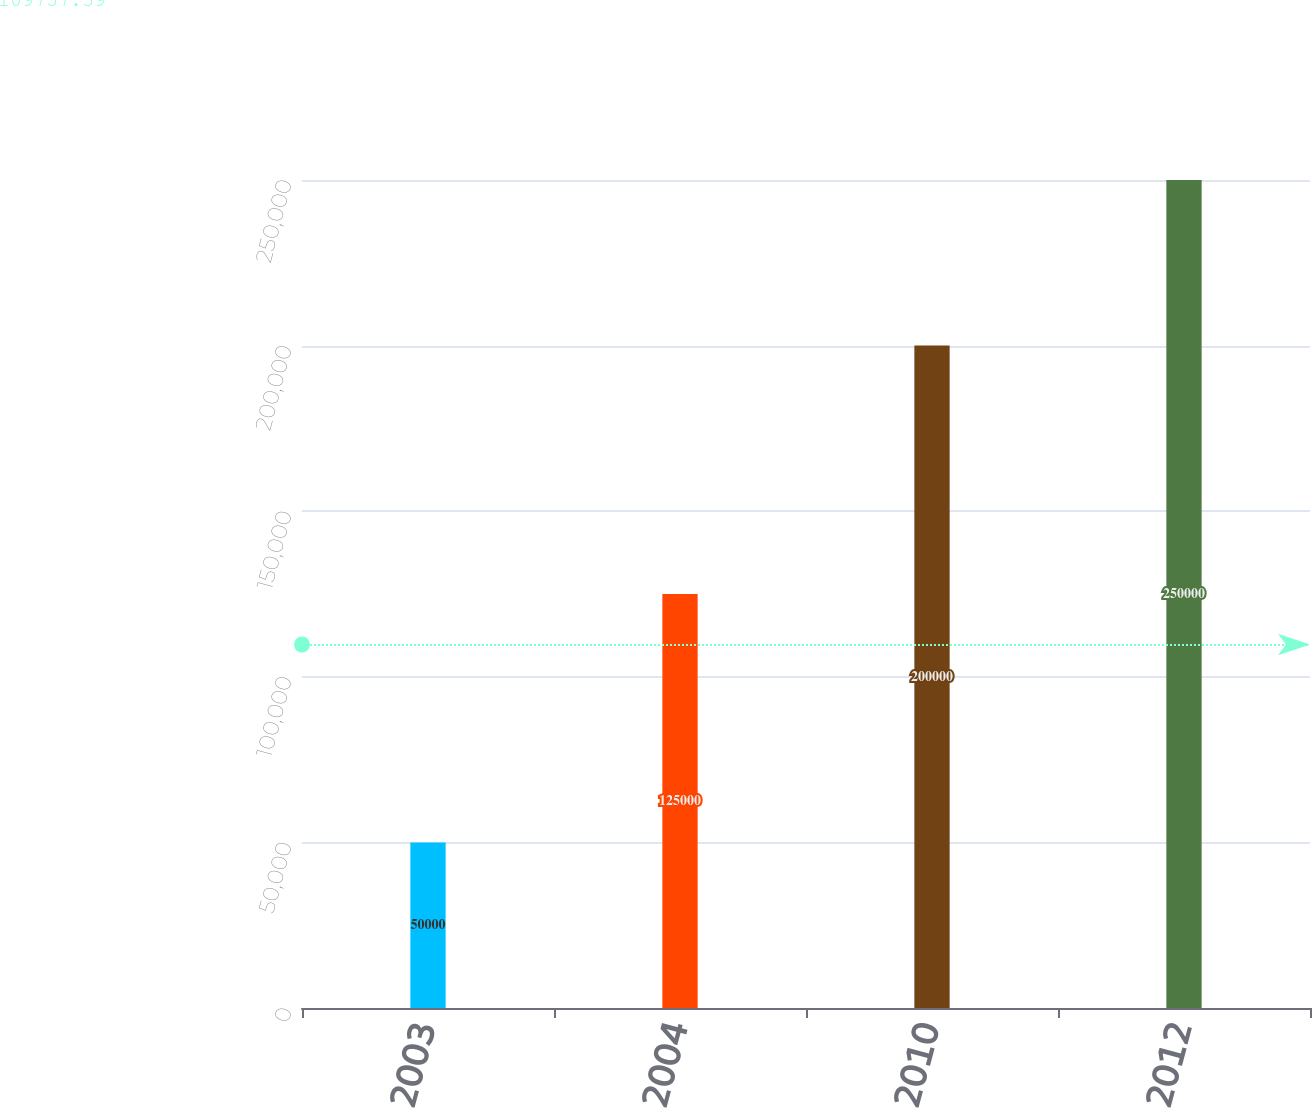<chart> <loc_0><loc_0><loc_500><loc_500><bar_chart><fcel>2003<fcel>2004<fcel>2010<fcel>2012<nl><fcel>50000<fcel>125000<fcel>200000<fcel>250000<nl></chart> 